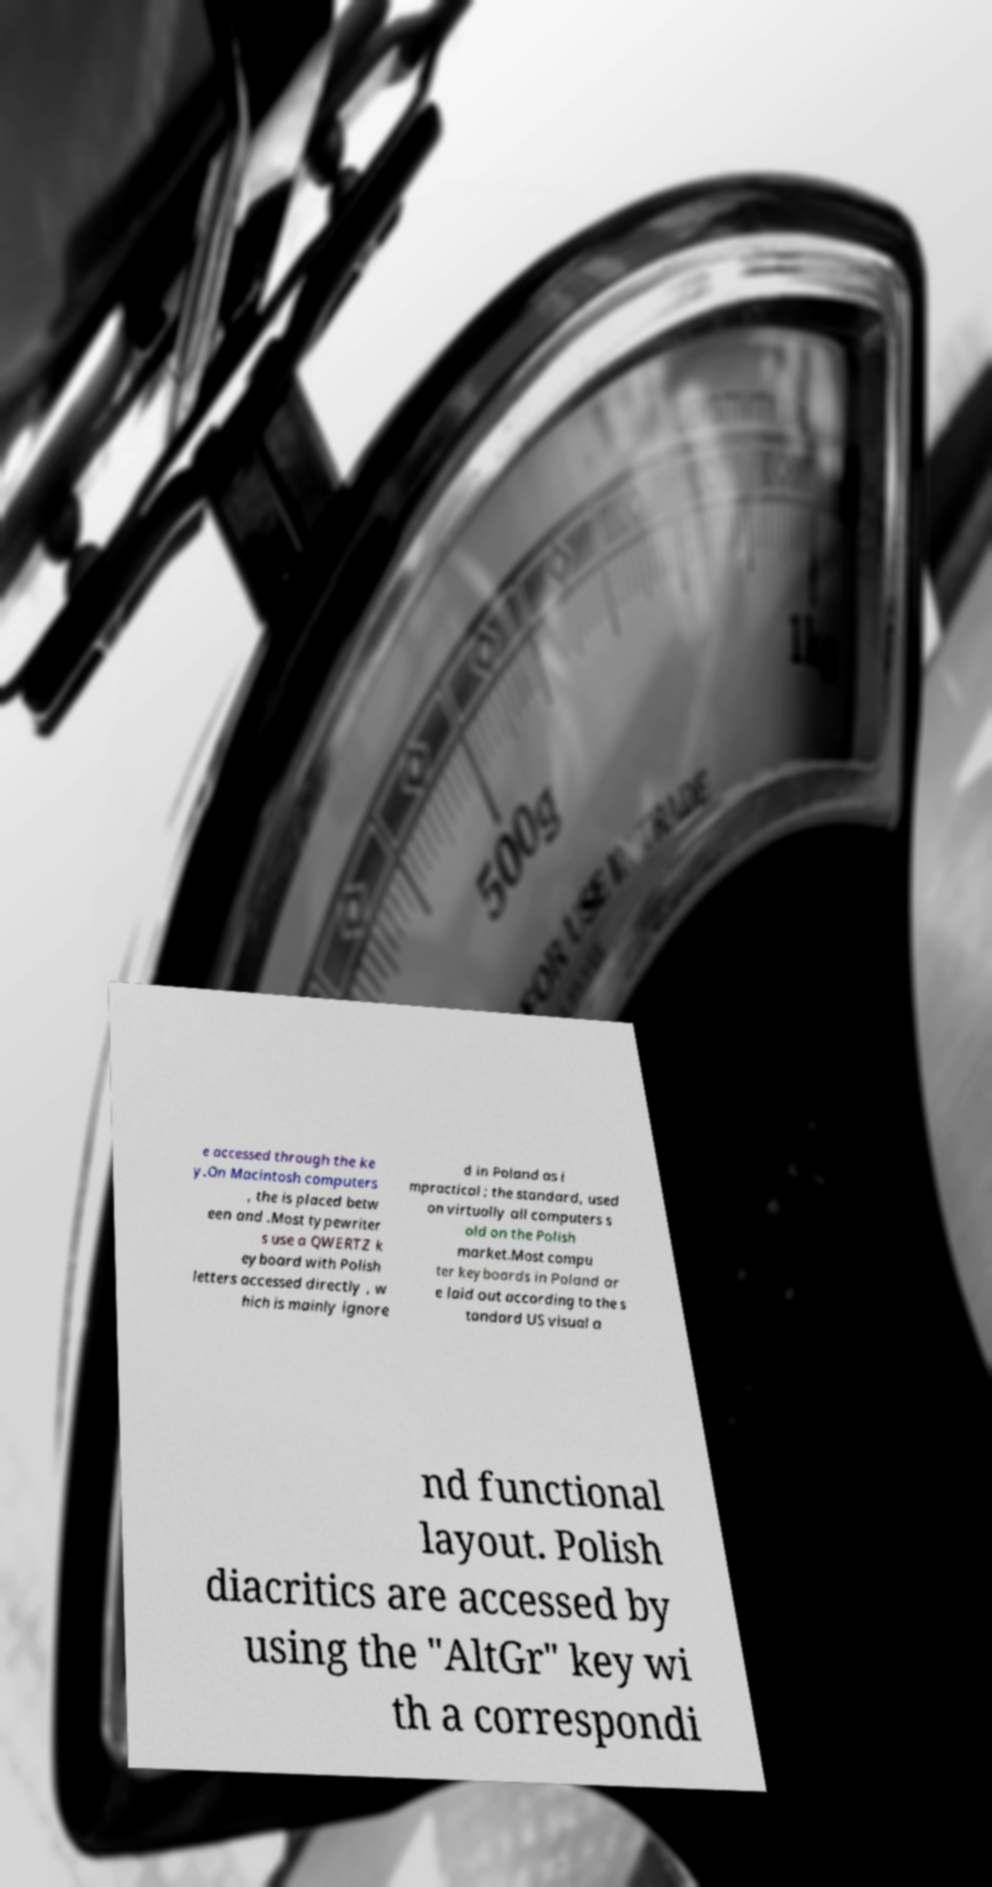What messages or text are displayed in this image? I need them in a readable, typed format. e accessed through the ke y.On Macintosh computers , the is placed betw een and .Most typewriter s use a QWERTZ k eyboard with Polish letters accessed directly , w hich is mainly ignore d in Poland as i mpractical ; the standard, used on virtually all computers s old on the Polish market.Most compu ter keyboards in Poland ar e laid out according to the s tandard US visual a nd functional layout. Polish diacritics are accessed by using the "AltGr" key wi th a correspondi 